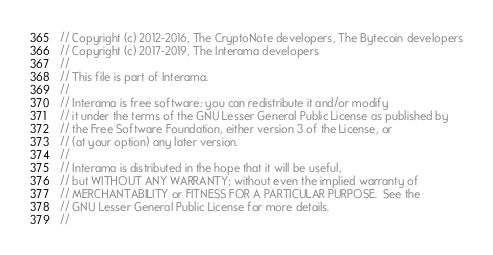Convert code to text. <code><loc_0><loc_0><loc_500><loc_500><_C_>// Copyright (c) 2012-2016, The CryptoNote developers, The Bytecoin developers
// Copyright (c) 2017-2019, The Interama developers
//
// This file is part of Interama.
//
// Interama is free software: you can redistribute it and/or modify
// it under the terms of the GNU Lesser General Public License as published by
// the Free Software Foundation, either version 3 of the License, or
// (at your option) any later version.
//
// Interama is distributed in the hope that it will be useful,
// but WITHOUT ANY WARRANTY; without even the implied warranty of
// MERCHANTABILITY or FITNESS FOR A PARTICULAR PURPOSE.  See the
// GNU Lesser General Public License for more details.
//</code> 